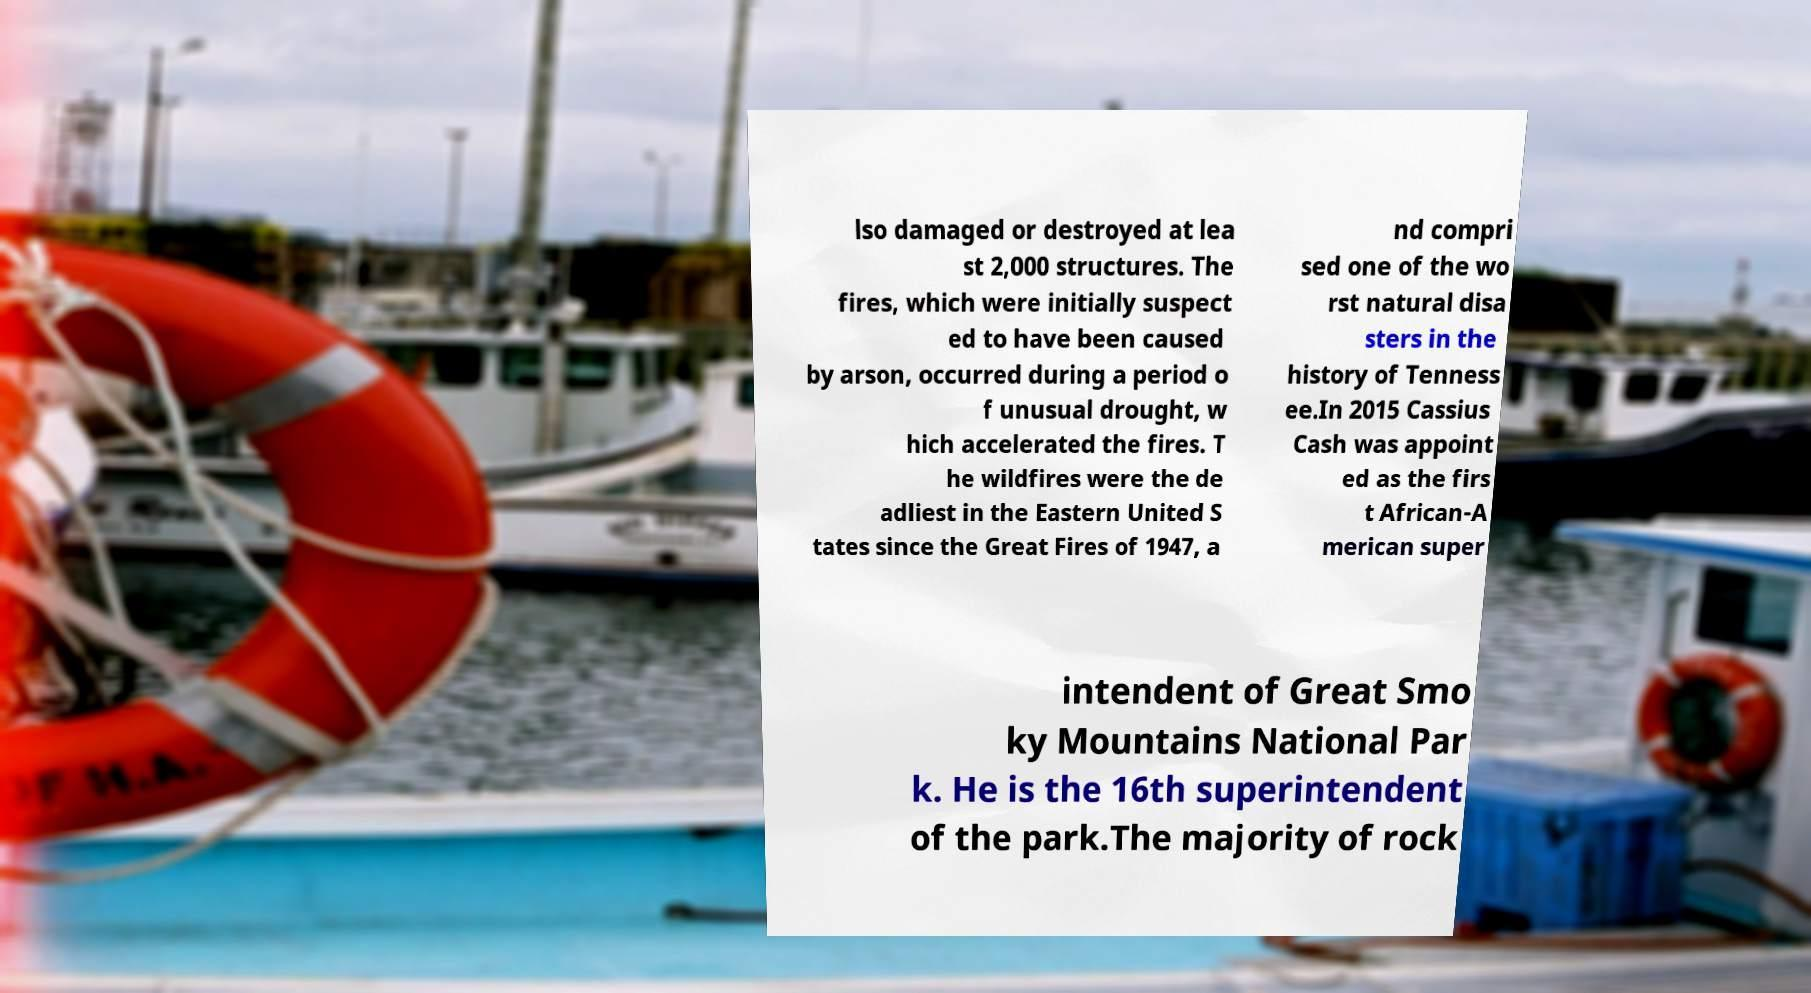Please identify and transcribe the text found in this image. lso damaged or destroyed at lea st 2,000 structures. The fires, which were initially suspect ed to have been caused by arson, occurred during a period o f unusual drought, w hich accelerated the fires. T he wildfires were the de adliest in the Eastern United S tates since the Great Fires of 1947, a nd compri sed one of the wo rst natural disa sters in the history of Tenness ee.In 2015 Cassius Cash was appoint ed as the firs t African-A merican super intendent of Great Smo ky Mountains National Par k. He is the 16th superintendent of the park.The majority of rock 